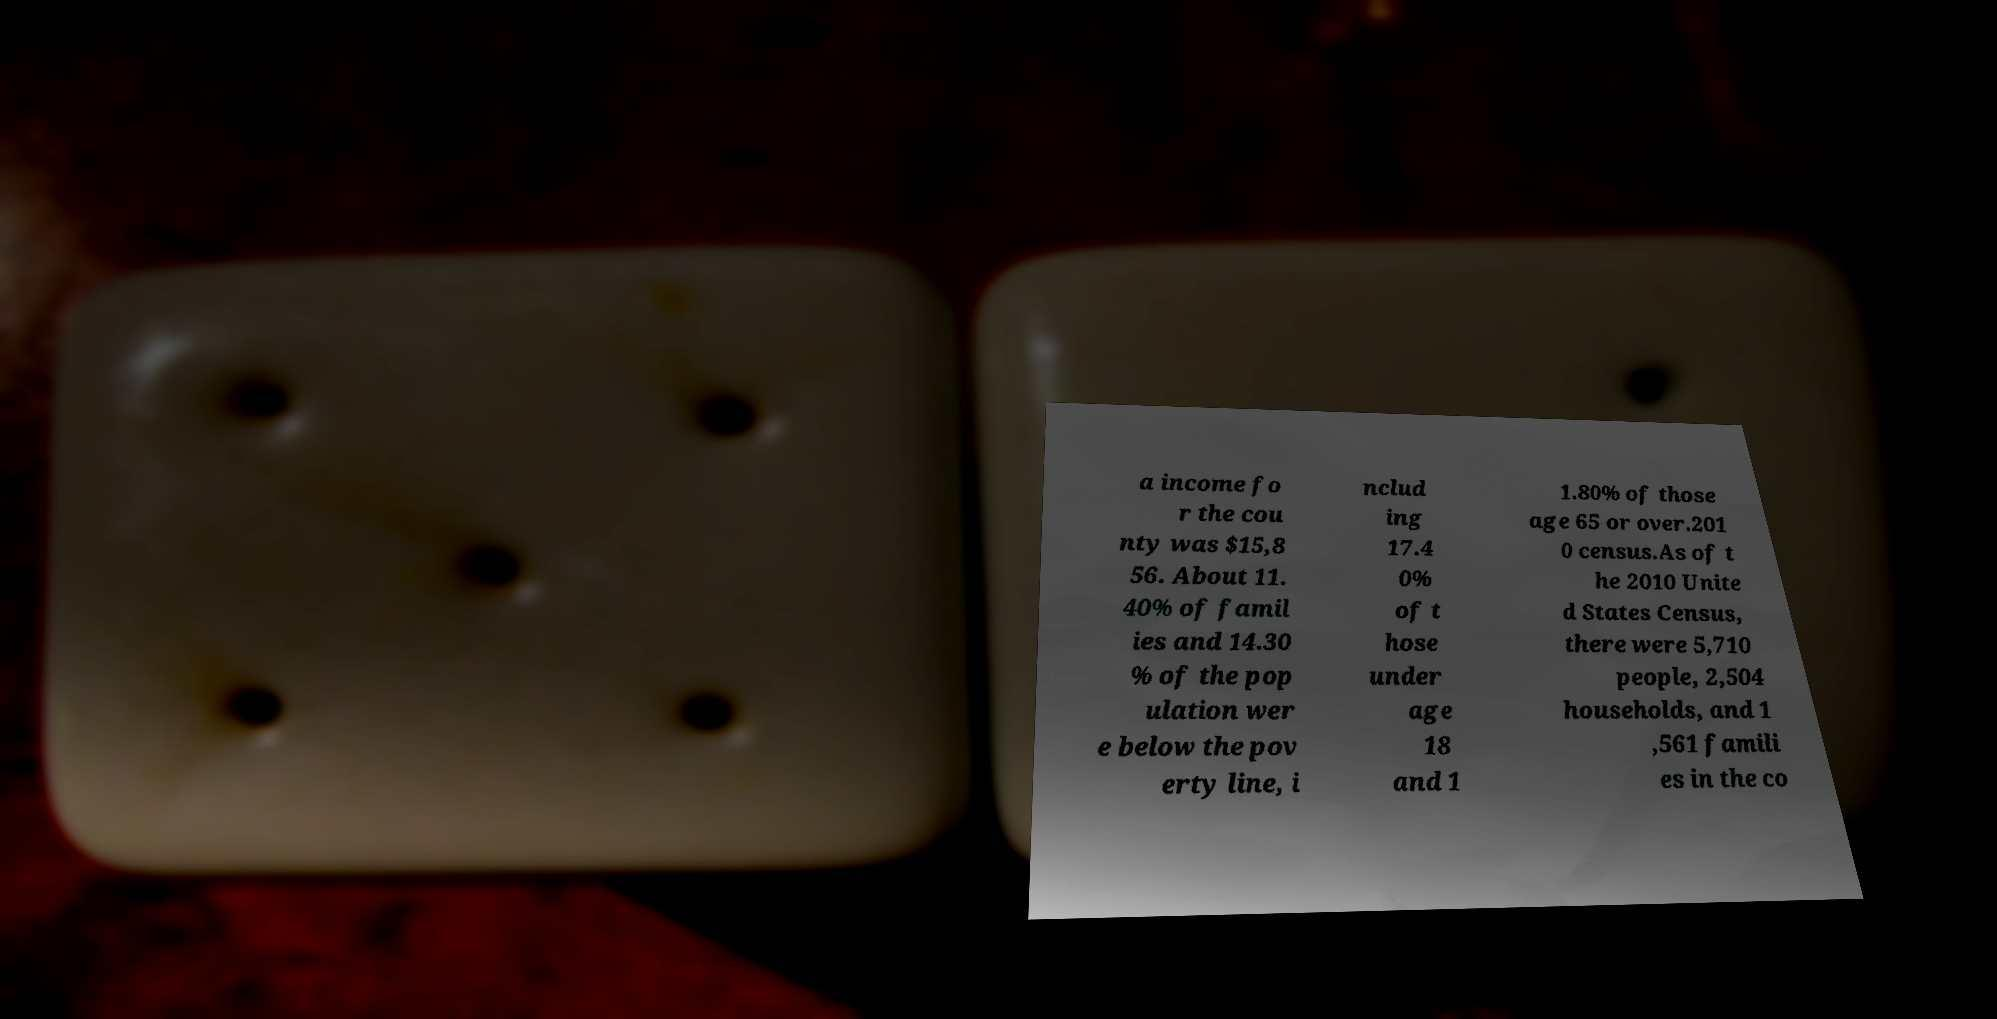What messages or text are displayed in this image? I need them in a readable, typed format. a income fo r the cou nty was $15,8 56. About 11. 40% of famil ies and 14.30 % of the pop ulation wer e below the pov erty line, i nclud ing 17.4 0% of t hose under age 18 and 1 1.80% of those age 65 or over.201 0 census.As of t he 2010 Unite d States Census, there were 5,710 people, 2,504 households, and 1 ,561 famili es in the co 